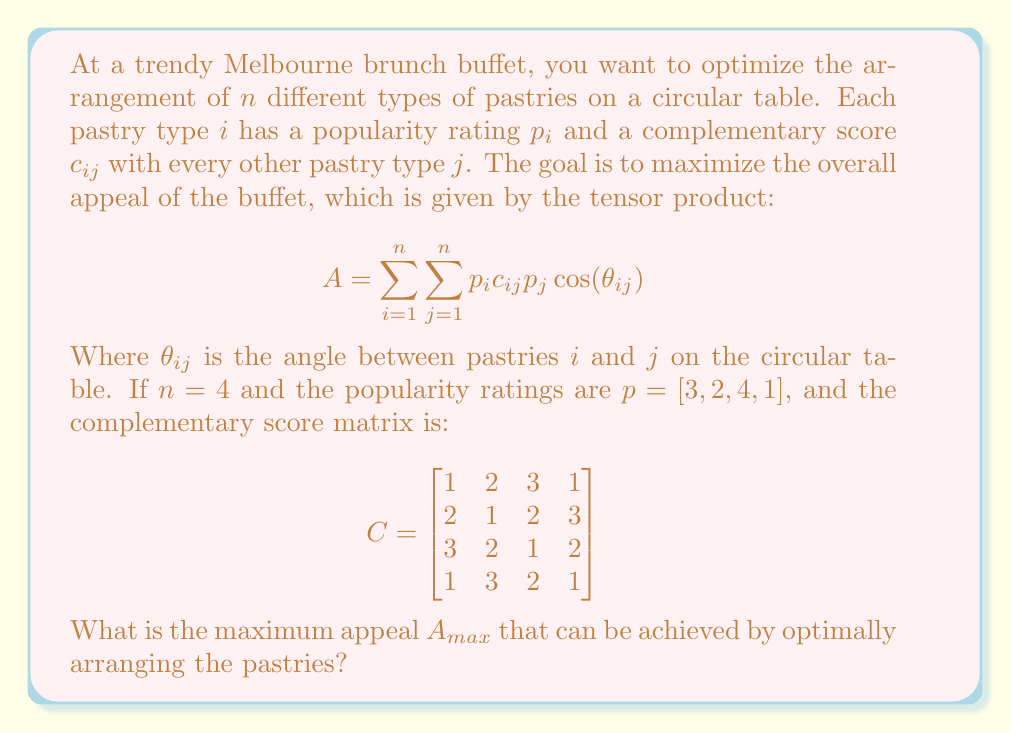Show me your answer to this math problem. To solve this problem, we need to follow these steps:

1) First, we need to understand that the maximum appeal will be achieved when pastries with high popularity ratings and high complementary scores are placed opposite each other on the circular table. This is because $\cos(\theta_{ij})$ is maximum (1) when $\theta_{ij} = 0°$ or $360°$, and minimum (-1) when $\theta_{ij} = 180°$.

2) Given the popularity ratings and complementary scores, we can see that pastry 3 has the highest popularity (4) and highest complementary scores with others. So, we should place it opposite to the pastry with the second-highest popularity, which is pastry 1.

3) Pastries 2 and 4 should be placed perpendicular to pastries 1 and 3.

4) The optimal arrangement would be: 3 - 2 - 1 - 4 (clockwise or counterclockwise).

5) Now, let's calculate the appeal:

   $A = (3 \cdot 1 \cdot 3 \cdot \cos(180°)) + (3 \cdot 2 \cdot 2 \cdot \cos(90°)) + (3 \cdot 3 \cdot 4 \cdot \cos(0°)) + (3 \cdot 1 \cdot 1 \cdot \cos(90°))$
      $+ (2 \cdot 2 \cdot 3 \cdot \cos(180°)) + (2 \cdot 1 \cdot 2 \cdot \cos(90°)) + (2 \cdot 2 \cdot 4 \cdot \cos(90°)) + (2 \cdot 3 \cdot 1 \cdot \cos(0°))$
      $+ (4 \cdot 3 \cdot 3 \cdot \cos(0°)) + (4 \cdot 2 \cdot 2 \cdot \cos(90°)) + (4 \cdot 1 \cdot 4 \cdot \cos(180°)) + (4 \cdot 2 \cdot 1 \cdot \cos(90°))$
      $+ (1 \cdot 1 \cdot 3 \cdot \cos(90°)) + (1 \cdot 3 \cdot 2 \cdot \cos(0°)) + (1 \cdot 2 \cdot 4 \cdot \cos(90°)) + (1 \cdot 1 \cdot 1 \cdot \cos(180°))$

6) Simplifying:
   $A = (-9) + (0) + (36) + (0) + (-12) + (0) + (0) + (6) + (36) + (0) + (-16) + (0) + (0) + (6) + (0) + (-1)$

7) Adding up all terms:
   $A_{max} = 46$
Answer: $46$ 